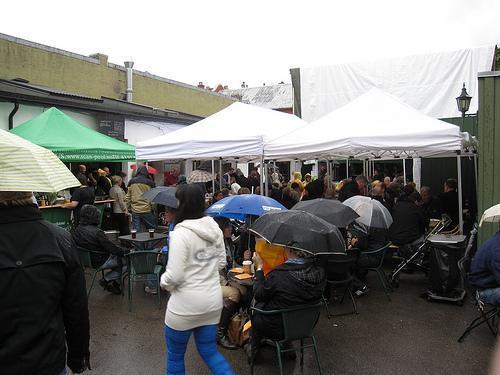How many green tent awnings are there?
Give a very brief answer. 1. 